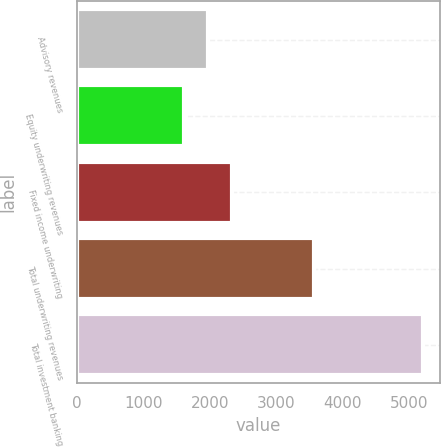Convert chart. <chart><loc_0><loc_0><loc_500><loc_500><bar_chart><fcel>Advisory revenues<fcel>Equity underwriting revenues<fcel>Fixed income underwriting<fcel>Total underwriting revenues<fcel>Total investment banking<nl><fcel>1972<fcel>1613<fcel>2331<fcel>3569<fcel>5203<nl></chart> 